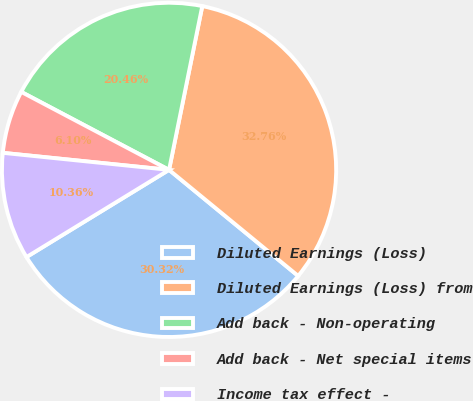<chart> <loc_0><loc_0><loc_500><loc_500><pie_chart><fcel>Diluted Earnings (Loss)<fcel>Diluted Earnings (Loss) from<fcel>Add back - Non-operating<fcel>Add back - Net special items<fcel>Income tax effect -<nl><fcel>30.32%<fcel>32.76%<fcel>20.46%<fcel>6.1%<fcel>10.36%<nl></chart> 